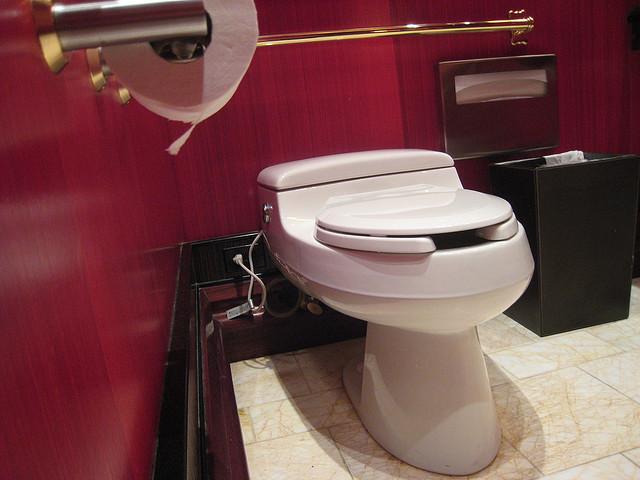What room is this?
Give a very brief answer. Bathroom. What color are the walls?
Keep it brief. Red. Is the toilet seat down?
Be succinct. Yes. Are the seats up or down?
Concise answer only. Down. 